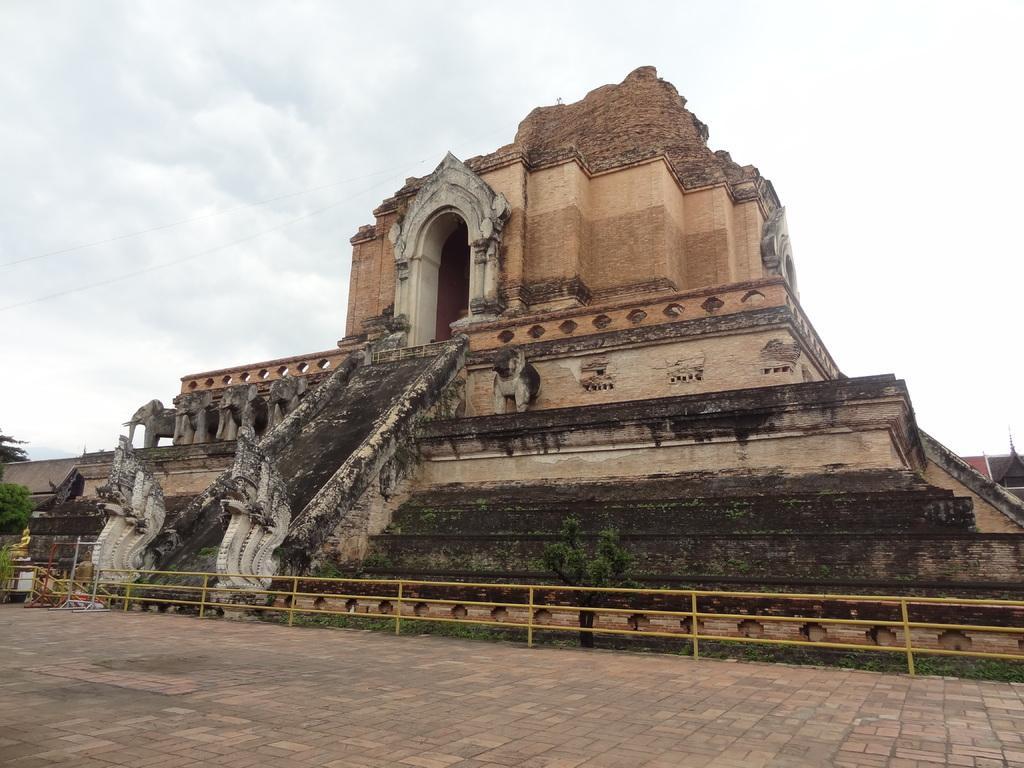In one or two sentences, can you explain what this image depicts? In this picture we can see a monument, in front of the monument we can find few metal rods and trees, and also we can see clouds. 